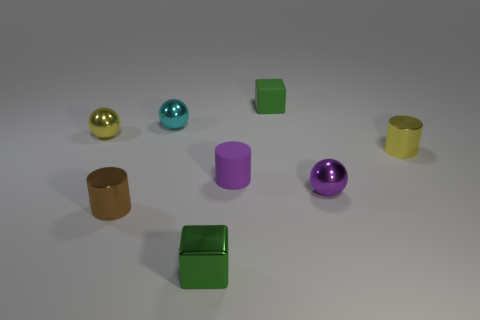Subtract all metallic cylinders. How many cylinders are left? 1 Add 2 tiny red metal things. How many objects exist? 10 Subtract all blocks. How many objects are left? 6 Subtract 0 blue blocks. How many objects are left? 8 Subtract all small brown shiny things. Subtract all tiny purple spheres. How many objects are left? 6 Add 2 yellow things. How many yellow things are left? 4 Add 4 tiny purple shiny cubes. How many tiny purple shiny cubes exist? 4 